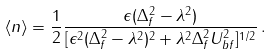Convert formula to latex. <formula><loc_0><loc_0><loc_500><loc_500>\langle n \rangle = \frac { 1 } { 2 } \frac { \epsilon ( \Delta _ { f } ^ { 2 } - \lambda ^ { 2 } ) } { [ \epsilon ^ { 2 } ( \Delta _ { f } ^ { 2 } - \lambda ^ { 2 } ) ^ { 2 } + \lambda ^ { 2 } \Delta _ { f } ^ { 2 } U _ { b f } ^ { 2 } ] ^ { 1 / 2 } } \, .</formula> 